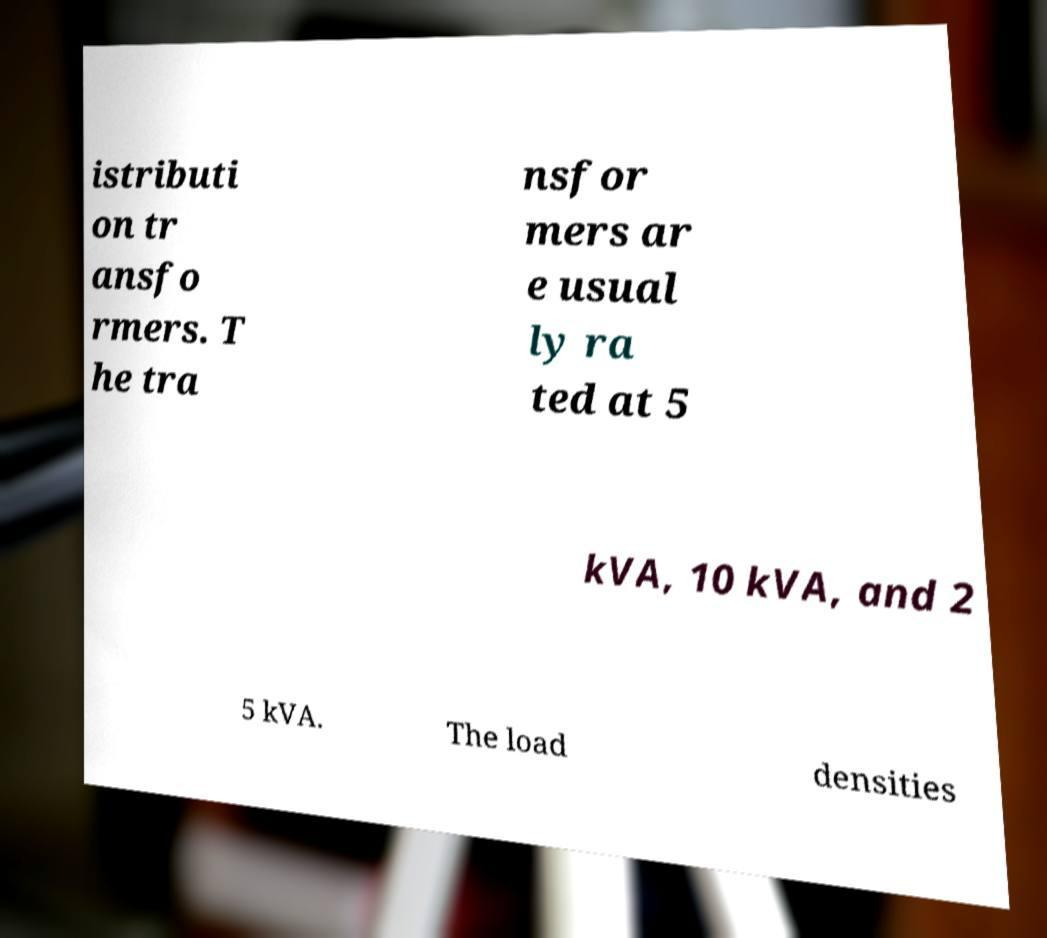There's text embedded in this image that I need extracted. Can you transcribe it verbatim? istributi on tr ansfo rmers. T he tra nsfor mers ar e usual ly ra ted at 5 kVA, 10 kVA, and 2 5 kVA. The load densities 